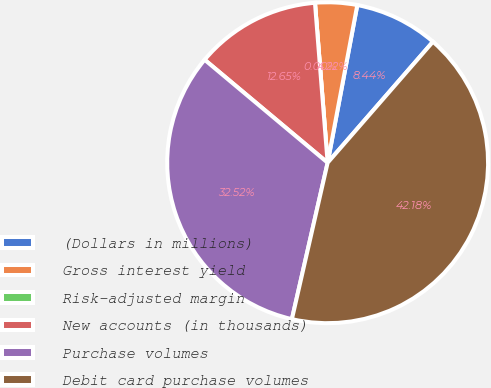Convert chart to OTSL. <chart><loc_0><loc_0><loc_500><loc_500><pie_chart><fcel>(Dollars in millions)<fcel>Gross interest yield<fcel>Risk-adjusted margin<fcel>New accounts (in thousands)<fcel>Purchase volumes<fcel>Debit card purchase volumes<nl><fcel>8.44%<fcel>4.22%<fcel>0.0%<fcel>12.65%<fcel>32.52%<fcel>42.18%<nl></chart> 